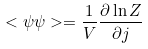<formula> <loc_0><loc_0><loc_500><loc_500>< \psi \psi > = \frac { 1 } { V } \frac { \partial \ln Z } { \partial j }</formula> 